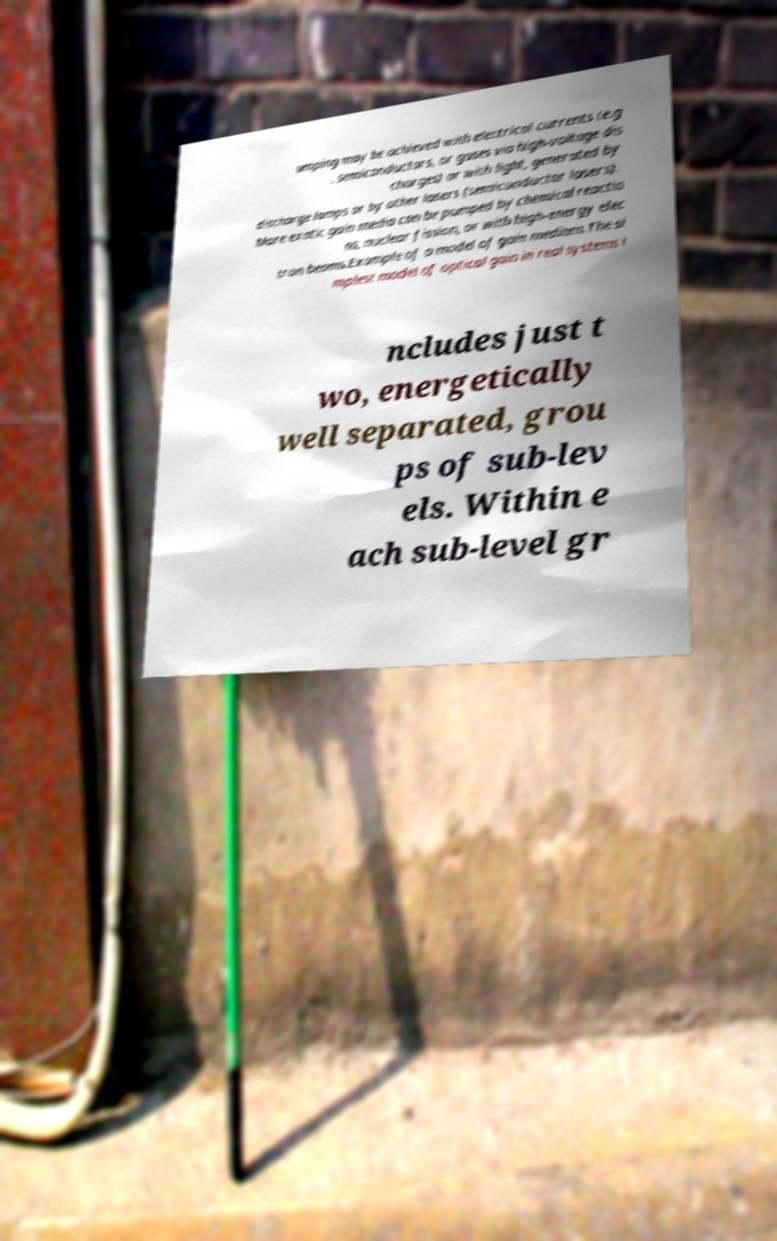Please read and relay the text visible in this image. What does it say? umping may be achieved with electrical currents (e.g . semiconductors, or gases via high-voltage dis charges) or with light, generated by discharge lamps or by other lasers (semiconductor lasers). More exotic gain media can be pumped by chemical reactio ns, nuclear fission, or with high-energy elec tron beams.Example of a model of gain medium.The si mplest model of optical gain in real systems i ncludes just t wo, energetically well separated, grou ps of sub-lev els. Within e ach sub-level gr 